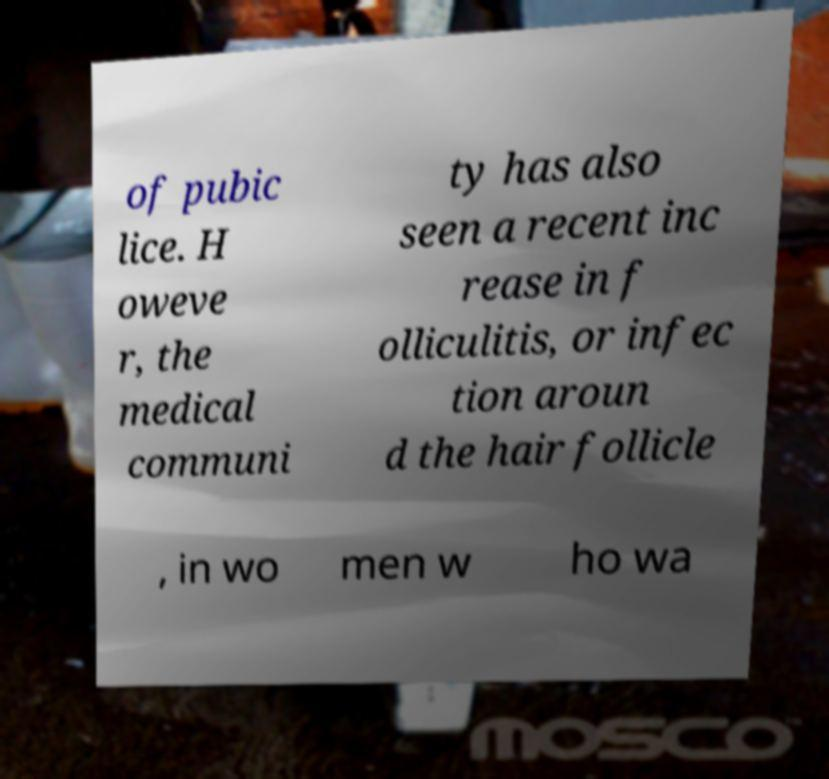There's text embedded in this image that I need extracted. Can you transcribe it verbatim? of pubic lice. H oweve r, the medical communi ty has also seen a recent inc rease in f olliculitis, or infec tion aroun d the hair follicle , in wo men w ho wa 